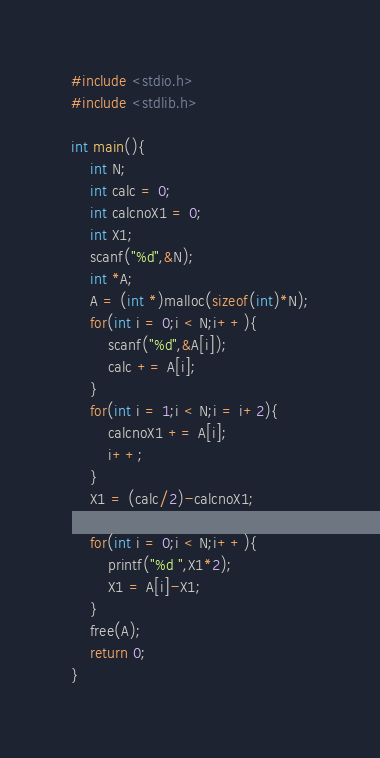<code> <loc_0><loc_0><loc_500><loc_500><_C_>#include <stdio.h>
#include <stdlib.h>

int main(){
	int N;
	int calc = 0;
	int calcnoX1 = 0;
	int X1;
	scanf("%d",&N);
	int *A;
	A = (int *)malloc(sizeof(int)*N);
	for(int i = 0;i < N;i++){
		scanf("%d",&A[i]);
		calc += A[i];
	}
	for(int i = 1;i < N;i = i+2){
		calcnoX1 += A[i];
		i++;
	}
	X1 = (calc/2)-calcnoX1;

	for(int i = 0;i < N;i++){
		printf("%d ",X1*2);
		X1 = A[i]-X1;
	}
	free(A);
	return 0;
}</code> 